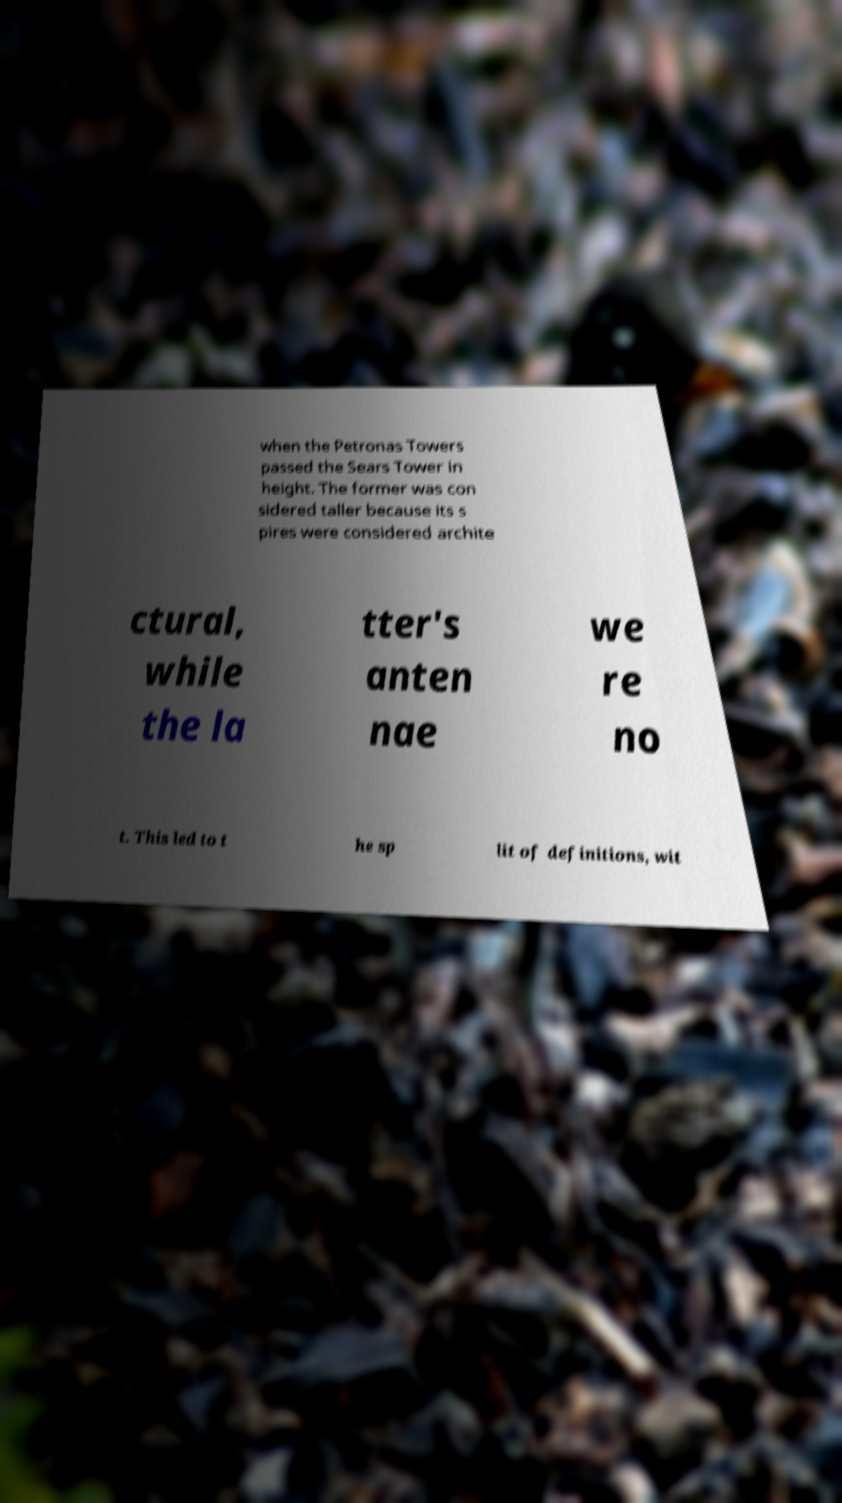Can you accurately transcribe the text from the provided image for me? when the Petronas Towers passed the Sears Tower in height. The former was con sidered taller because its s pires were considered archite ctural, while the la tter's anten nae we re no t. This led to t he sp lit of definitions, wit 